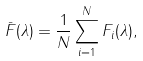<formula> <loc_0><loc_0><loc_500><loc_500>\bar { F } ( \lambda ) = \frac { 1 } { N } \sum ^ { N } _ { i = 1 } F _ { i } ( \lambda ) ,</formula> 